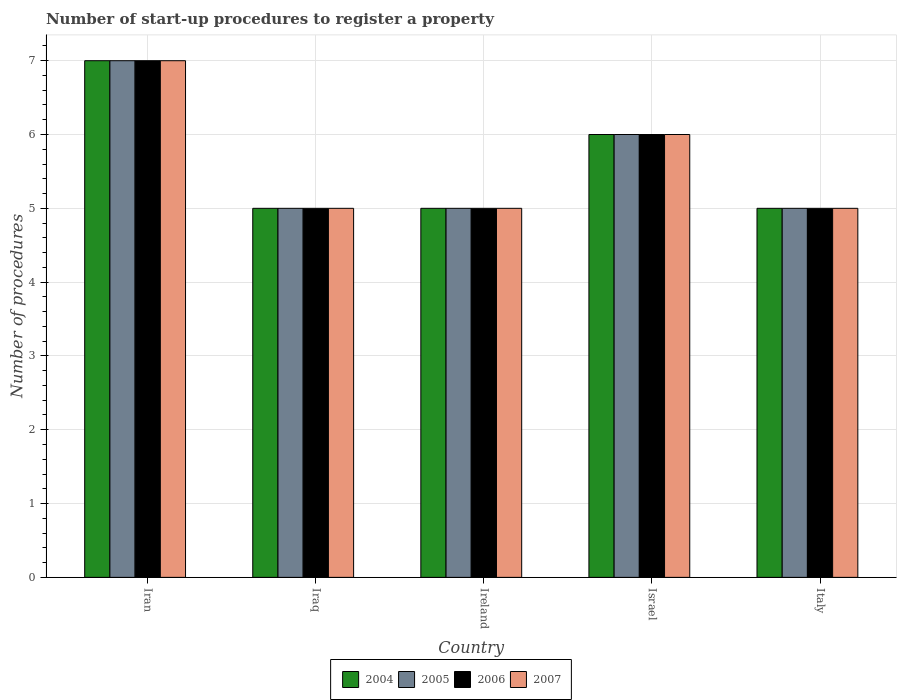How many different coloured bars are there?
Your answer should be compact. 4. How many groups of bars are there?
Ensure brevity in your answer.  5. How many bars are there on the 2nd tick from the left?
Offer a very short reply. 4. How many bars are there on the 1st tick from the right?
Your response must be concise. 4. What is the label of the 1st group of bars from the left?
Give a very brief answer. Iran. In how many cases, is the number of bars for a given country not equal to the number of legend labels?
Your answer should be compact. 0. What is the number of procedures required to register a property in 2006 in Iraq?
Provide a succinct answer. 5. In which country was the number of procedures required to register a property in 2005 maximum?
Keep it short and to the point. Iran. In which country was the number of procedures required to register a property in 2006 minimum?
Your response must be concise. Iraq. What is the total number of procedures required to register a property in 2007 in the graph?
Offer a very short reply. 28. What is the difference between the number of procedures required to register a property in 2004 in Ireland and the number of procedures required to register a property in 2005 in Israel?
Your answer should be compact. -1. What is the average number of procedures required to register a property in 2006 per country?
Ensure brevity in your answer.  5.6. In how many countries, is the number of procedures required to register a property in 2004 greater than 6.6?
Provide a short and direct response. 1. What is the ratio of the number of procedures required to register a property in 2007 in Iran to that in Israel?
Give a very brief answer. 1.17. Is the number of procedures required to register a property in 2007 in Israel less than that in Italy?
Make the answer very short. No. What is the difference between the highest and the second highest number of procedures required to register a property in 2006?
Provide a short and direct response. -1. In how many countries, is the number of procedures required to register a property in 2007 greater than the average number of procedures required to register a property in 2007 taken over all countries?
Offer a terse response. 2. Is the sum of the number of procedures required to register a property in 2006 in Iran and Israel greater than the maximum number of procedures required to register a property in 2005 across all countries?
Provide a succinct answer. Yes. Is it the case that in every country, the sum of the number of procedures required to register a property in 2004 and number of procedures required to register a property in 2005 is greater than the sum of number of procedures required to register a property in 2006 and number of procedures required to register a property in 2007?
Give a very brief answer. No. How many bars are there?
Your response must be concise. 20. How many countries are there in the graph?
Offer a terse response. 5. What is the difference between two consecutive major ticks on the Y-axis?
Your answer should be very brief. 1. Does the graph contain any zero values?
Make the answer very short. No. Does the graph contain grids?
Make the answer very short. Yes. How many legend labels are there?
Ensure brevity in your answer.  4. What is the title of the graph?
Keep it short and to the point. Number of start-up procedures to register a property. What is the label or title of the X-axis?
Give a very brief answer. Country. What is the label or title of the Y-axis?
Make the answer very short. Number of procedures. What is the Number of procedures of 2004 in Iran?
Your response must be concise. 7. What is the Number of procedures in 2006 in Iran?
Give a very brief answer. 7. What is the Number of procedures in 2004 in Iraq?
Make the answer very short. 5. What is the Number of procedures of 2005 in Iraq?
Offer a very short reply. 5. What is the Number of procedures of 2004 in Ireland?
Keep it short and to the point. 5. What is the Number of procedures of 2005 in Ireland?
Provide a short and direct response. 5. What is the Number of procedures in 2004 in Israel?
Make the answer very short. 6. What is the Number of procedures of 2005 in Israel?
Make the answer very short. 6. What is the Number of procedures of 2006 in Israel?
Give a very brief answer. 6. What is the Number of procedures in 2007 in Israel?
Offer a terse response. 6. What is the Number of procedures in 2004 in Italy?
Make the answer very short. 5. What is the Number of procedures of 2005 in Italy?
Offer a very short reply. 5. What is the Number of procedures of 2006 in Italy?
Ensure brevity in your answer.  5. What is the Number of procedures in 2007 in Italy?
Keep it short and to the point. 5. Across all countries, what is the maximum Number of procedures in 2004?
Provide a short and direct response. 7. Across all countries, what is the maximum Number of procedures in 2007?
Provide a short and direct response. 7. Across all countries, what is the minimum Number of procedures in 2005?
Your answer should be very brief. 5. Across all countries, what is the minimum Number of procedures in 2006?
Your answer should be compact. 5. Across all countries, what is the minimum Number of procedures of 2007?
Keep it short and to the point. 5. What is the total Number of procedures of 2004 in the graph?
Provide a succinct answer. 28. What is the total Number of procedures of 2006 in the graph?
Ensure brevity in your answer.  28. What is the difference between the Number of procedures of 2006 in Iran and that in Iraq?
Offer a terse response. 2. What is the difference between the Number of procedures in 2007 in Iran and that in Iraq?
Provide a short and direct response. 2. What is the difference between the Number of procedures of 2004 in Iran and that in Ireland?
Offer a terse response. 2. What is the difference between the Number of procedures in 2006 in Iran and that in Ireland?
Make the answer very short. 2. What is the difference between the Number of procedures of 2007 in Iran and that in Ireland?
Offer a very short reply. 2. What is the difference between the Number of procedures in 2004 in Iran and that in Israel?
Keep it short and to the point. 1. What is the difference between the Number of procedures of 2006 in Iran and that in Israel?
Ensure brevity in your answer.  1. What is the difference between the Number of procedures of 2004 in Iran and that in Italy?
Provide a succinct answer. 2. What is the difference between the Number of procedures in 2005 in Iran and that in Italy?
Make the answer very short. 2. What is the difference between the Number of procedures in 2006 in Iran and that in Italy?
Offer a terse response. 2. What is the difference between the Number of procedures in 2007 in Iraq and that in Ireland?
Ensure brevity in your answer.  0. What is the difference between the Number of procedures in 2004 in Iraq and that in Israel?
Your response must be concise. -1. What is the difference between the Number of procedures of 2006 in Iraq and that in Israel?
Offer a very short reply. -1. What is the difference between the Number of procedures in 2004 in Iraq and that in Italy?
Keep it short and to the point. 0. What is the difference between the Number of procedures of 2005 in Iraq and that in Italy?
Your response must be concise. 0. What is the difference between the Number of procedures in 2006 in Iraq and that in Italy?
Keep it short and to the point. 0. What is the difference between the Number of procedures in 2006 in Ireland and that in Israel?
Ensure brevity in your answer.  -1. What is the difference between the Number of procedures of 2007 in Ireland and that in Israel?
Your response must be concise. -1. What is the difference between the Number of procedures in 2004 in Ireland and that in Italy?
Make the answer very short. 0. What is the difference between the Number of procedures in 2004 in Israel and that in Italy?
Make the answer very short. 1. What is the difference between the Number of procedures of 2005 in Israel and that in Italy?
Your answer should be compact. 1. What is the difference between the Number of procedures in 2005 in Iran and the Number of procedures in 2006 in Iraq?
Make the answer very short. 2. What is the difference between the Number of procedures of 2005 in Iran and the Number of procedures of 2007 in Iraq?
Offer a very short reply. 2. What is the difference between the Number of procedures of 2006 in Iran and the Number of procedures of 2007 in Iraq?
Your response must be concise. 2. What is the difference between the Number of procedures in 2004 in Iran and the Number of procedures in 2006 in Ireland?
Keep it short and to the point. 2. What is the difference between the Number of procedures in 2004 in Iran and the Number of procedures in 2007 in Ireland?
Your answer should be very brief. 2. What is the difference between the Number of procedures of 2005 in Iran and the Number of procedures of 2006 in Ireland?
Keep it short and to the point. 2. What is the difference between the Number of procedures of 2005 in Iran and the Number of procedures of 2007 in Ireland?
Provide a succinct answer. 2. What is the difference between the Number of procedures of 2004 in Iran and the Number of procedures of 2005 in Israel?
Offer a very short reply. 1. What is the difference between the Number of procedures of 2004 in Iran and the Number of procedures of 2006 in Israel?
Your answer should be compact. 1. What is the difference between the Number of procedures of 2004 in Iran and the Number of procedures of 2007 in Israel?
Provide a succinct answer. 1. What is the difference between the Number of procedures of 2005 in Iran and the Number of procedures of 2007 in Israel?
Your response must be concise. 1. What is the difference between the Number of procedures of 2006 in Iran and the Number of procedures of 2007 in Israel?
Offer a terse response. 1. What is the difference between the Number of procedures in 2004 in Iran and the Number of procedures in 2005 in Italy?
Your response must be concise. 2. What is the difference between the Number of procedures of 2005 in Iran and the Number of procedures of 2006 in Italy?
Make the answer very short. 2. What is the difference between the Number of procedures of 2005 in Iran and the Number of procedures of 2007 in Italy?
Provide a short and direct response. 2. What is the difference between the Number of procedures of 2004 in Iraq and the Number of procedures of 2006 in Ireland?
Ensure brevity in your answer.  0. What is the difference between the Number of procedures of 2005 in Iraq and the Number of procedures of 2006 in Ireland?
Provide a short and direct response. 0. What is the difference between the Number of procedures of 2004 in Iraq and the Number of procedures of 2005 in Israel?
Offer a very short reply. -1. What is the difference between the Number of procedures of 2006 in Iraq and the Number of procedures of 2007 in Israel?
Your answer should be very brief. -1. What is the difference between the Number of procedures in 2004 in Iraq and the Number of procedures in 2005 in Italy?
Your answer should be compact. 0. What is the difference between the Number of procedures in 2005 in Iraq and the Number of procedures in 2006 in Italy?
Keep it short and to the point. 0. What is the difference between the Number of procedures in 2006 in Iraq and the Number of procedures in 2007 in Italy?
Your response must be concise. 0. What is the difference between the Number of procedures in 2004 in Ireland and the Number of procedures in 2006 in Israel?
Provide a succinct answer. -1. What is the difference between the Number of procedures in 2005 in Ireland and the Number of procedures in 2006 in Israel?
Your answer should be compact. -1. What is the difference between the Number of procedures of 2005 in Ireland and the Number of procedures of 2007 in Israel?
Your answer should be compact. -1. What is the difference between the Number of procedures of 2006 in Ireland and the Number of procedures of 2007 in Israel?
Your response must be concise. -1. What is the difference between the Number of procedures in 2004 in Ireland and the Number of procedures in 2005 in Italy?
Provide a succinct answer. 0. What is the difference between the Number of procedures of 2004 in Ireland and the Number of procedures of 2006 in Italy?
Provide a short and direct response. 0. What is the difference between the Number of procedures in 2005 in Ireland and the Number of procedures in 2006 in Italy?
Your answer should be very brief. 0. What is the difference between the Number of procedures of 2005 in Ireland and the Number of procedures of 2007 in Italy?
Provide a succinct answer. 0. What is the difference between the Number of procedures of 2004 in Israel and the Number of procedures of 2005 in Italy?
Provide a short and direct response. 1. What is the difference between the Number of procedures in 2004 in Israel and the Number of procedures in 2006 in Italy?
Make the answer very short. 1. What is the difference between the Number of procedures of 2005 in Israel and the Number of procedures of 2006 in Italy?
Provide a short and direct response. 1. What is the difference between the Number of procedures of 2005 in Israel and the Number of procedures of 2007 in Italy?
Offer a terse response. 1. What is the average Number of procedures in 2007 per country?
Make the answer very short. 5.6. What is the difference between the Number of procedures in 2005 and Number of procedures in 2007 in Iran?
Your answer should be very brief. 0. What is the difference between the Number of procedures of 2004 and Number of procedures of 2007 in Iraq?
Make the answer very short. 0. What is the difference between the Number of procedures of 2005 and Number of procedures of 2006 in Iraq?
Ensure brevity in your answer.  0. What is the difference between the Number of procedures in 2005 and Number of procedures in 2007 in Iraq?
Offer a terse response. 0. What is the difference between the Number of procedures in 2006 and Number of procedures in 2007 in Iraq?
Your response must be concise. 0. What is the difference between the Number of procedures in 2004 and Number of procedures in 2005 in Ireland?
Give a very brief answer. 0. What is the difference between the Number of procedures of 2004 and Number of procedures of 2007 in Ireland?
Your response must be concise. 0. What is the difference between the Number of procedures in 2004 and Number of procedures in 2005 in Israel?
Give a very brief answer. 0. What is the difference between the Number of procedures of 2004 and Number of procedures of 2007 in Israel?
Offer a terse response. 0. What is the difference between the Number of procedures of 2006 and Number of procedures of 2007 in Israel?
Offer a very short reply. 0. What is the difference between the Number of procedures of 2004 and Number of procedures of 2006 in Italy?
Ensure brevity in your answer.  0. What is the difference between the Number of procedures of 2004 and Number of procedures of 2007 in Italy?
Ensure brevity in your answer.  0. What is the difference between the Number of procedures in 2005 and Number of procedures in 2006 in Italy?
Give a very brief answer. 0. What is the difference between the Number of procedures in 2005 and Number of procedures in 2007 in Italy?
Give a very brief answer. 0. What is the difference between the Number of procedures in 2006 and Number of procedures in 2007 in Italy?
Provide a short and direct response. 0. What is the ratio of the Number of procedures in 2004 in Iran to that in Iraq?
Keep it short and to the point. 1.4. What is the ratio of the Number of procedures of 2006 in Iran to that in Iraq?
Offer a terse response. 1.4. What is the ratio of the Number of procedures in 2007 in Iran to that in Iraq?
Provide a succinct answer. 1.4. What is the ratio of the Number of procedures in 2004 in Iran to that in Ireland?
Provide a short and direct response. 1.4. What is the ratio of the Number of procedures of 2005 in Iran to that in Israel?
Your response must be concise. 1.17. What is the ratio of the Number of procedures in 2007 in Iran to that in Israel?
Keep it short and to the point. 1.17. What is the ratio of the Number of procedures in 2004 in Iran to that in Italy?
Provide a short and direct response. 1.4. What is the ratio of the Number of procedures in 2005 in Iran to that in Italy?
Give a very brief answer. 1.4. What is the ratio of the Number of procedures of 2004 in Iraq to that in Ireland?
Keep it short and to the point. 1. What is the ratio of the Number of procedures of 2006 in Iraq to that in Ireland?
Your answer should be compact. 1. What is the ratio of the Number of procedures in 2007 in Iraq to that in Ireland?
Offer a terse response. 1. What is the ratio of the Number of procedures of 2005 in Iraq to that in Israel?
Offer a very short reply. 0.83. What is the ratio of the Number of procedures of 2006 in Iraq to that in Israel?
Your answer should be compact. 0.83. What is the ratio of the Number of procedures in 2007 in Iraq to that in Israel?
Offer a very short reply. 0.83. What is the ratio of the Number of procedures in 2004 in Iraq to that in Italy?
Offer a very short reply. 1. What is the ratio of the Number of procedures in 2006 in Iraq to that in Italy?
Your response must be concise. 1. What is the ratio of the Number of procedures in 2004 in Ireland to that in Israel?
Your response must be concise. 0.83. What is the ratio of the Number of procedures of 2005 in Ireland to that in Israel?
Your answer should be very brief. 0.83. What is the ratio of the Number of procedures of 2006 in Ireland to that in Israel?
Make the answer very short. 0.83. What is the ratio of the Number of procedures in 2004 in Ireland to that in Italy?
Ensure brevity in your answer.  1. What is the ratio of the Number of procedures of 2005 in Ireland to that in Italy?
Make the answer very short. 1. What is the ratio of the Number of procedures of 2006 in Ireland to that in Italy?
Provide a succinct answer. 1. What is the ratio of the Number of procedures in 2007 in Ireland to that in Italy?
Ensure brevity in your answer.  1. What is the ratio of the Number of procedures in 2004 in Israel to that in Italy?
Your answer should be very brief. 1.2. What is the ratio of the Number of procedures in 2005 in Israel to that in Italy?
Ensure brevity in your answer.  1.2. What is the ratio of the Number of procedures of 2006 in Israel to that in Italy?
Your answer should be compact. 1.2. What is the ratio of the Number of procedures in 2007 in Israel to that in Italy?
Offer a terse response. 1.2. What is the difference between the highest and the second highest Number of procedures in 2004?
Give a very brief answer. 1. What is the difference between the highest and the second highest Number of procedures of 2005?
Provide a succinct answer. 1. What is the difference between the highest and the second highest Number of procedures in 2006?
Offer a terse response. 1. What is the difference between the highest and the lowest Number of procedures of 2005?
Offer a very short reply. 2. 